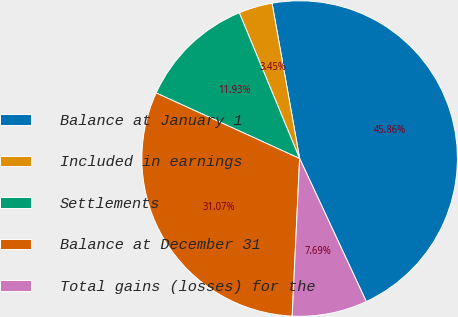Convert chart. <chart><loc_0><loc_0><loc_500><loc_500><pie_chart><fcel>Balance at January 1<fcel>Included in earnings<fcel>Settlements<fcel>Balance at December 31<fcel>Total gains (losses) for the<nl><fcel>45.86%<fcel>3.45%<fcel>11.93%<fcel>31.07%<fcel>7.69%<nl></chart> 